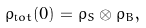Convert formula to latex. <formula><loc_0><loc_0><loc_500><loc_500>\rho _ { \mathrm t o t } ( 0 ) = \rho _ { S } \otimes \rho _ { B } ,</formula> 